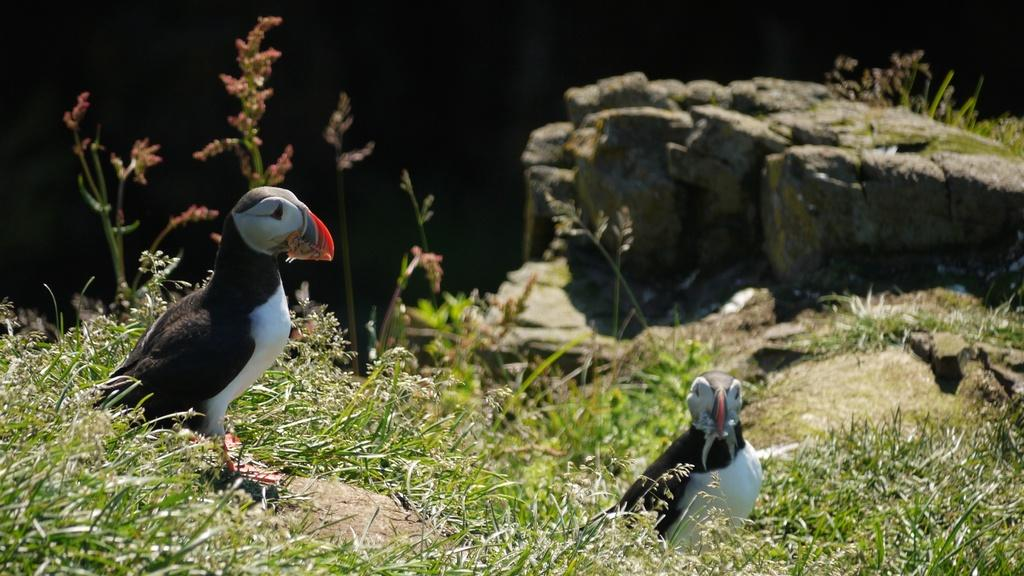What type of animals are on the ground in the image? There are birds on the ground in the image. What type of vegetation is visible in the image? There is grass and plants visible in the image. What is the rock used for in the image? The rock is a natural element in the image and does not have a specific use. What is the caption of the image? There is no caption present in the image. How many units are visible in the image? The concept of "units" is not applicable to the elements in the image, as they are natural objects and not man-made structures. 